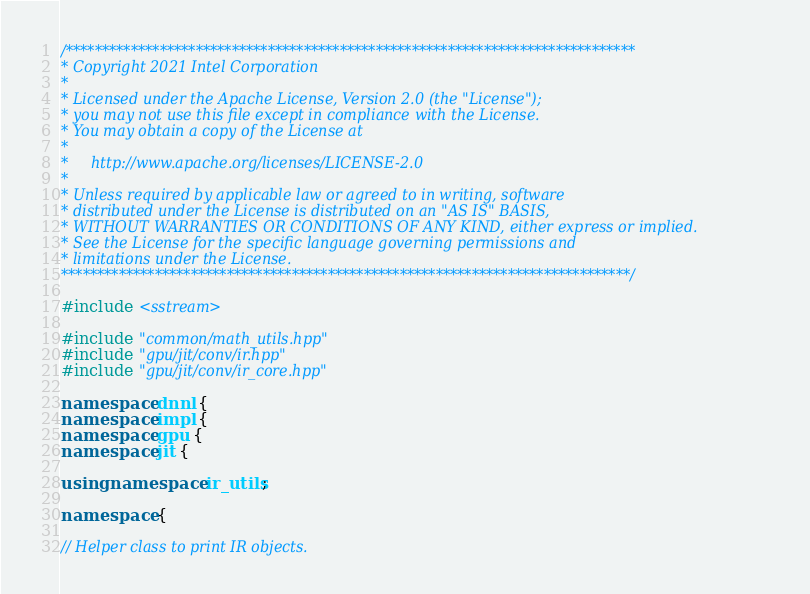<code> <loc_0><loc_0><loc_500><loc_500><_C++_>/*******************************************************************************
* Copyright 2021 Intel Corporation
*
* Licensed under the Apache License, Version 2.0 (the "License");
* you may not use this file except in compliance with the License.
* You may obtain a copy of the License at
*
*     http://www.apache.org/licenses/LICENSE-2.0
*
* Unless required by applicable law or agreed to in writing, software
* distributed under the License is distributed on an "AS IS" BASIS,
* WITHOUT WARRANTIES OR CONDITIONS OF ANY KIND, either express or implied.
* See the License for the specific language governing permissions and
* limitations under the License.
*******************************************************************************/

#include <sstream>

#include "common/math_utils.hpp"
#include "gpu/jit/conv/ir.hpp"
#include "gpu/jit/conv/ir_core.hpp"

namespace dnnl {
namespace impl {
namespace gpu {
namespace jit {

using namespace ir_utils;

namespace {

// Helper class to print IR objects.</code> 